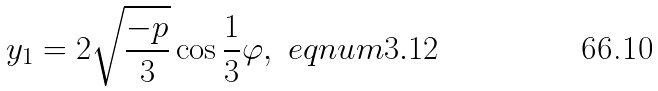Convert formula to latex. <formula><loc_0><loc_0><loc_500><loc_500>y _ { 1 } = 2 \sqrt { \frac { - p } { 3 } } \cos \frac { 1 } { 3 } \varphi , \ e q n u m { 3 . 1 2 }</formula> 